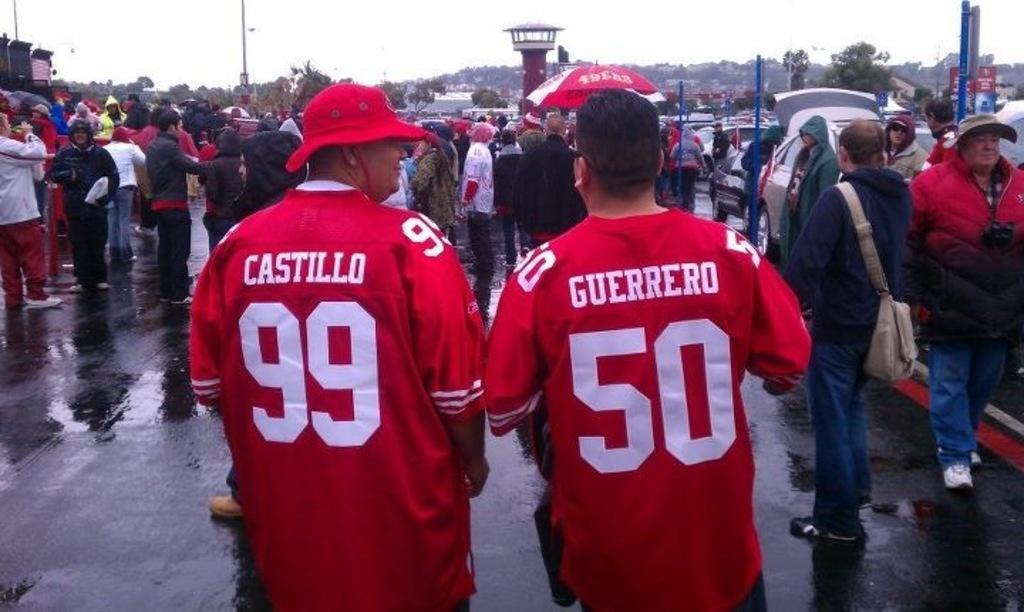<image>
Present a compact description of the photo's key features. Castillo and Guerrero walk side by side on the wet pavement. 